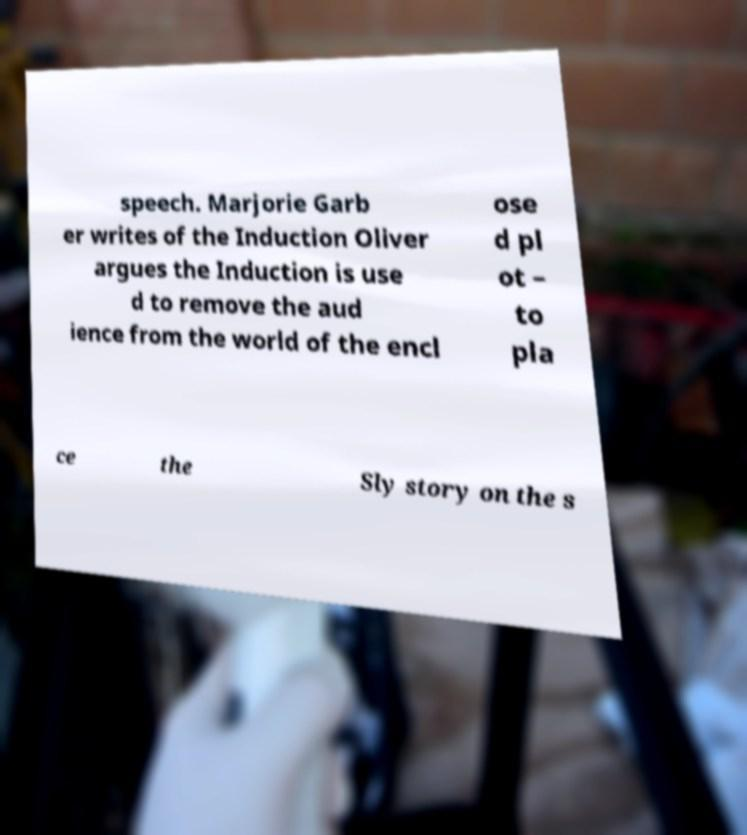What messages or text are displayed in this image? I need them in a readable, typed format. speech. Marjorie Garb er writes of the Induction Oliver argues the Induction is use d to remove the aud ience from the world of the encl ose d pl ot – to pla ce the Sly story on the s 